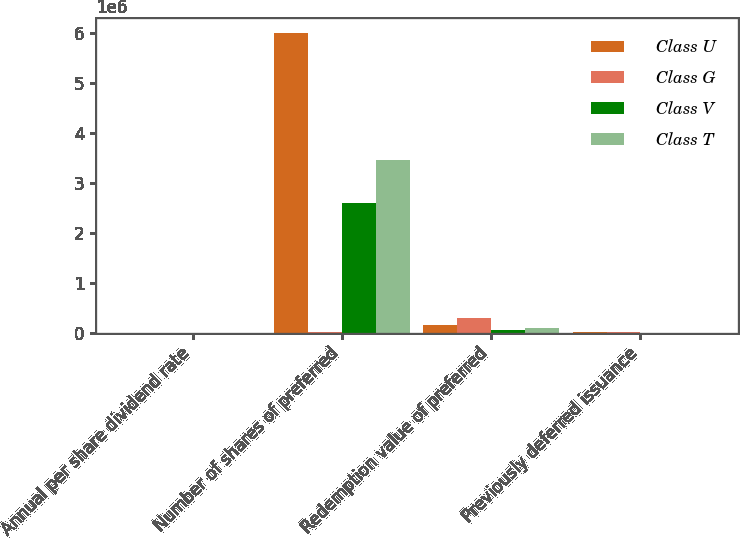Convert chart to OTSL. <chart><loc_0><loc_0><loc_500><loc_500><stacked_bar_chart><ecel><fcel>Annual per share dividend rate<fcel>Number of shares of preferred<fcel>Redemption value of preferred<fcel>Previously deferred issuance<nl><fcel>Class U<fcel>8<fcel>6e+06<fcel>150000<fcel>5193<nl><fcel>Class G<fcel>7.75<fcel>10137<fcel>300000<fcel>10137<nl><fcel>Class V<fcel>8<fcel>2.5875e+06<fcel>64688<fcel>2350<nl><fcel>Class T<fcel>7.88<fcel>3.45e+06<fcel>86250<fcel>2987<nl></chart> 